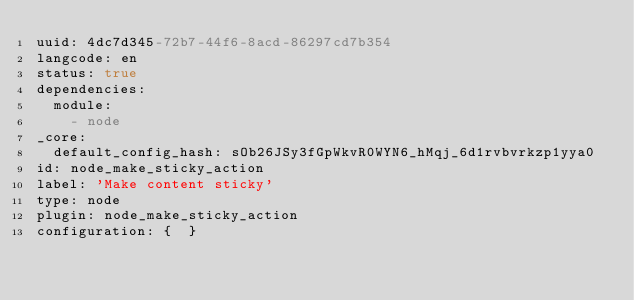<code> <loc_0><loc_0><loc_500><loc_500><_YAML_>uuid: 4dc7d345-72b7-44f6-8acd-86297cd7b354
langcode: en
status: true
dependencies:
  module:
    - node
_core:
  default_config_hash: sOb26JSy3fGpWkvR0WYN6_hMqj_6d1rvbvrkzp1yya0
id: node_make_sticky_action
label: 'Make content sticky'
type: node
plugin: node_make_sticky_action
configuration: {  }
</code> 